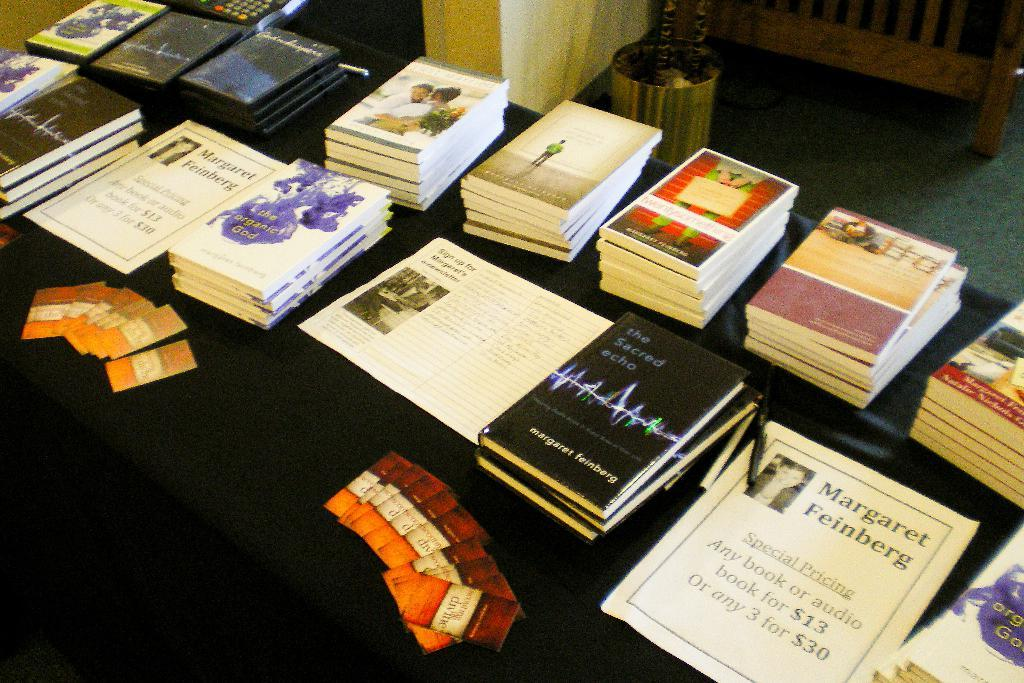<image>
Give a short and clear explanation of the subsequent image. books and pamphlets on a table including one by Margaret Feinberg 